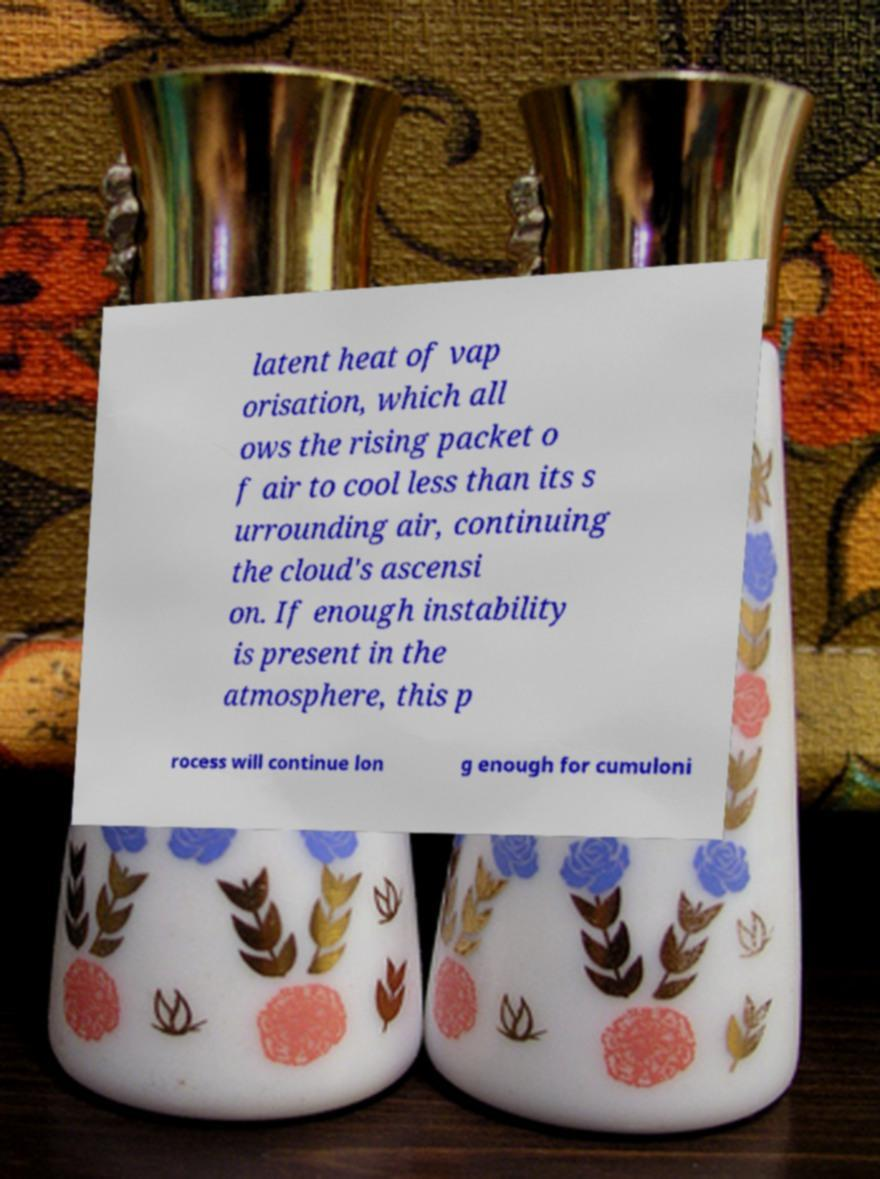Can you read and provide the text displayed in the image?This photo seems to have some interesting text. Can you extract and type it out for me? latent heat of vap orisation, which all ows the rising packet o f air to cool less than its s urrounding air, continuing the cloud's ascensi on. If enough instability is present in the atmosphere, this p rocess will continue lon g enough for cumuloni 